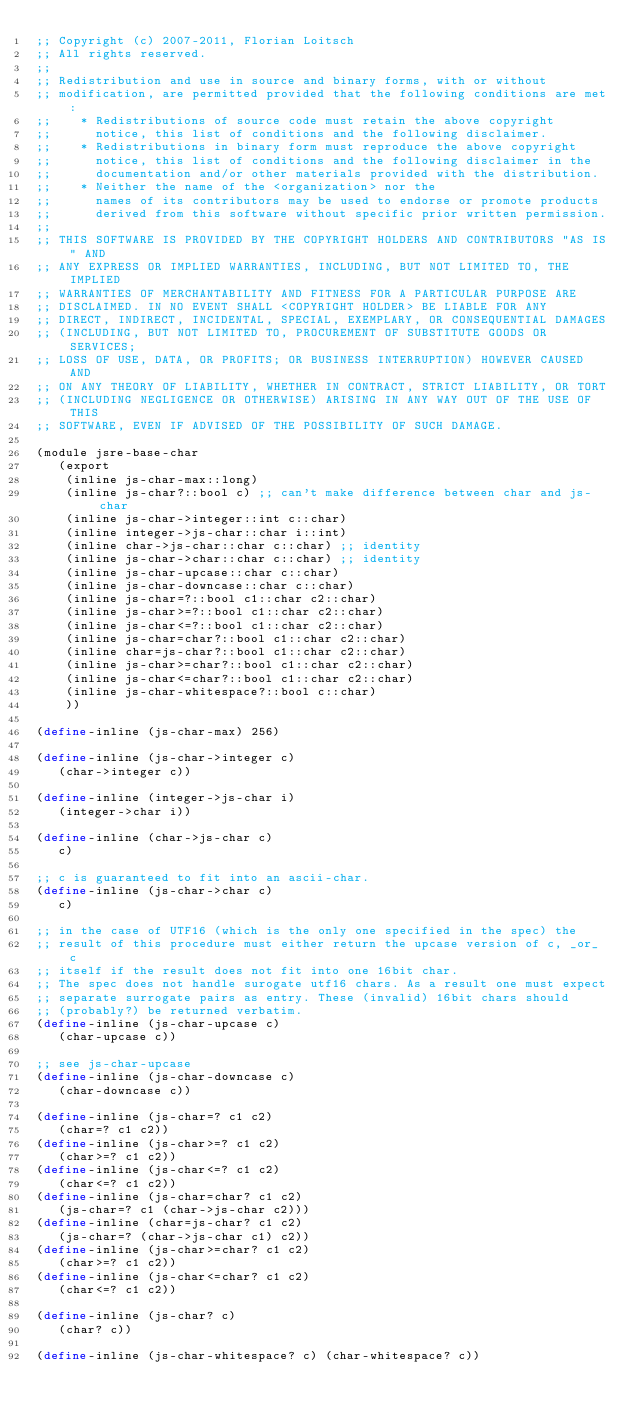<code> <loc_0><loc_0><loc_500><loc_500><_Scheme_>;; Copyright (c) 2007-2011, Florian Loitsch
;; All rights reserved.
;;
;; Redistribution and use in source and binary forms, with or without
;; modification, are permitted provided that the following conditions are met:
;;    * Redistributions of source code must retain the above copyright
;;      notice, this list of conditions and the following disclaimer.
;;    * Redistributions in binary form must reproduce the above copyright
;;      notice, this list of conditions and the following disclaimer in the
;;      documentation and/or other materials provided with the distribution.
;;    * Neither the name of the <organization> nor the
;;      names of its contributors may be used to endorse or promote products
;;      derived from this software without specific prior written permission.
;;
;; THIS SOFTWARE IS PROVIDED BY THE COPYRIGHT HOLDERS AND CONTRIBUTORS "AS IS" AND
;; ANY EXPRESS OR IMPLIED WARRANTIES, INCLUDING, BUT NOT LIMITED TO, THE IMPLIED
;; WARRANTIES OF MERCHANTABILITY AND FITNESS FOR A PARTICULAR PURPOSE ARE
;; DISCLAIMED. IN NO EVENT SHALL <COPYRIGHT HOLDER> BE LIABLE FOR ANY
;; DIRECT, INDIRECT, INCIDENTAL, SPECIAL, EXEMPLARY, OR CONSEQUENTIAL DAMAGES
;; (INCLUDING, BUT NOT LIMITED TO, PROCUREMENT OF SUBSTITUTE GOODS OR SERVICES;
;; LOSS OF USE, DATA, OR PROFITS; OR BUSINESS INTERRUPTION) HOWEVER CAUSED AND
;; ON ANY THEORY OF LIABILITY, WHETHER IN CONTRACT, STRICT LIABILITY, OR TORT
;; (INCLUDING NEGLIGENCE OR OTHERWISE) ARISING IN ANY WAY OUT OF THE USE OF THIS
;; SOFTWARE, EVEN IF ADVISED OF THE POSSIBILITY OF SUCH DAMAGE.

(module jsre-base-char
   (export
    (inline js-char-max::long)
    (inline js-char?::bool c) ;; can't make difference between char and js-char
    (inline js-char->integer::int c::char)
    (inline integer->js-char::char i::int)
    (inline char->js-char::char c::char) ;; identity
    (inline js-char->char::char c::char) ;; identity
    (inline js-char-upcase::char c::char)
    (inline js-char-downcase::char c::char)
    (inline js-char=?::bool c1::char c2::char)
    (inline js-char>=?::bool c1::char c2::char)
    (inline js-char<=?::bool c1::char c2::char)
    (inline js-char=char?::bool c1::char c2::char)
    (inline char=js-char?::bool c1::char c2::char)
    (inline js-char>=char?::bool c1::char c2::char)
    (inline js-char<=char?::bool c1::char c2::char)
    (inline js-char-whitespace?::bool c::char)
    ))

(define-inline (js-char-max) 256)

(define-inline (js-char->integer c)
   (char->integer c))

(define-inline (integer->js-char i)
   (integer->char i))

(define-inline (char->js-char c)
   c)

;; c is guaranteed to fit into an ascii-char.
(define-inline (js-char->char c)
   c)

;; in the case of UTF16 (which is the only one specified in the spec) the
;; result of this procedure must either return the upcase version of c, _or_ c
;; itself if the result does not fit into one 16bit char.
;; The spec does not handle surogate utf16 chars. As a result one must expect
;; separate surrogate pairs as entry. These (invalid) 16bit chars should
;; (probably?) be returned verbatim.
(define-inline (js-char-upcase c)
   (char-upcase c))

;; see js-char-upcase
(define-inline (js-char-downcase c)
   (char-downcase c))

(define-inline (js-char=? c1 c2)
   (char=? c1 c2))
(define-inline (js-char>=? c1 c2)
   (char>=? c1 c2))
(define-inline (js-char<=? c1 c2)
   (char<=? c1 c2))
(define-inline (js-char=char? c1 c2)
   (js-char=? c1 (char->js-char c2)))
(define-inline (char=js-char? c1 c2)
   (js-char=? (char->js-char c1) c2))
(define-inline (js-char>=char? c1 c2)
   (char>=? c1 c2))
(define-inline (js-char<=char? c1 c2)
   (char<=? c1 c2))

(define-inline (js-char? c)
   (char? c))

(define-inline (js-char-whitespace? c) (char-whitespace? c))
</code> 